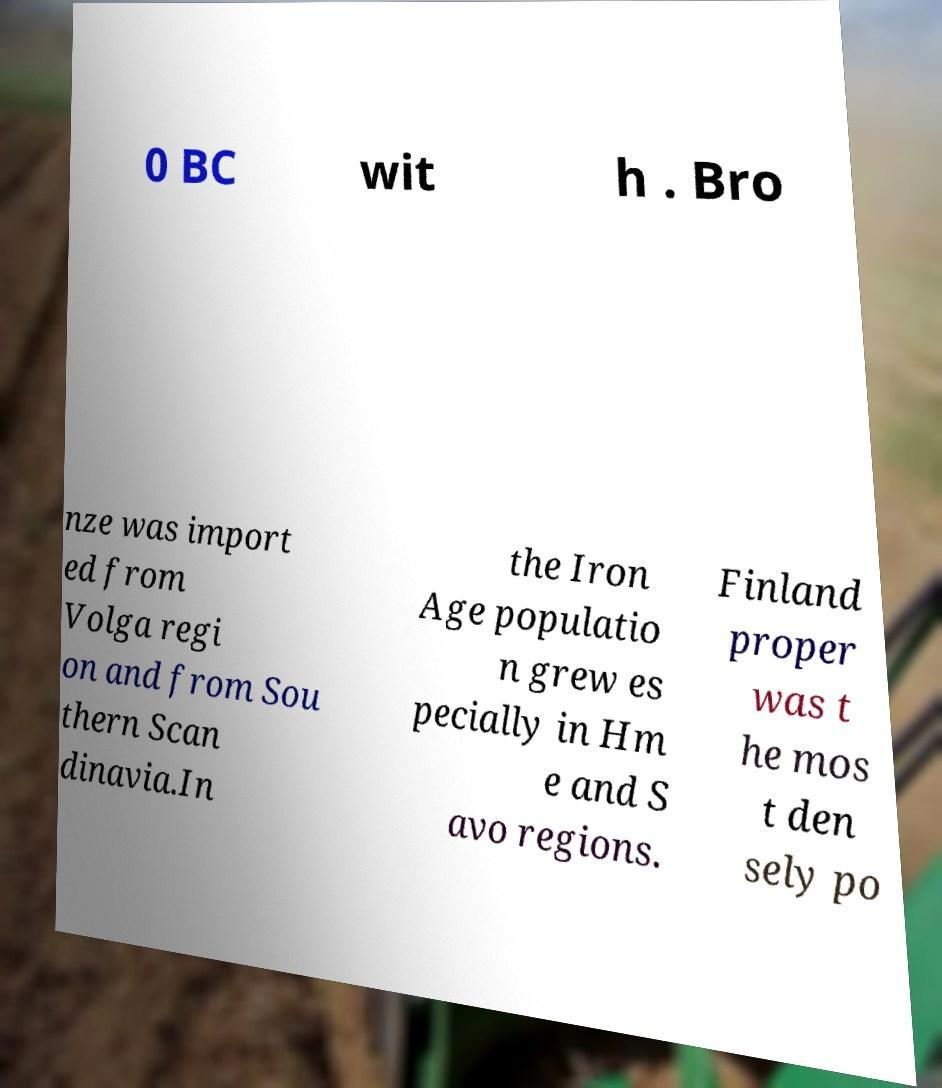Could you extract and type out the text from this image? 0 BC wit h . Bro nze was import ed from Volga regi on and from Sou thern Scan dinavia.In the Iron Age populatio n grew es pecially in Hm e and S avo regions. Finland proper was t he mos t den sely po 